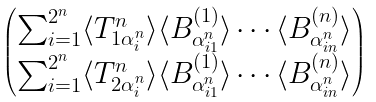<formula> <loc_0><loc_0><loc_500><loc_500>\begin{pmatrix} \sum _ { i = 1 } ^ { 2 ^ { n } } \langle T _ { 1 \alpha _ { i } ^ { n } } ^ { n } \rangle \langle B _ { \alpha _ { i 1 } ^ { n } } ^ { ( 1 ) } \rangle \cdots \langle B _ { \alpha _ { i n } ^ { n } } ^ { ( n ) } \rangle \\ \sum _ { i = 1 } ^ { 2 ^ { n } } \langle T _ { 2 \alpha _ { i } ^ { n } } ^ { n } \rangle \langle B _ { \alpha _ { i 1 } ^ { n } } ^ { ( 1 ) } \rangle \cdots \langle B _ { \alpha _ { i n } ^ { n } } ^ { ( n ) } \rangle \end{pmatrix}</formula> 